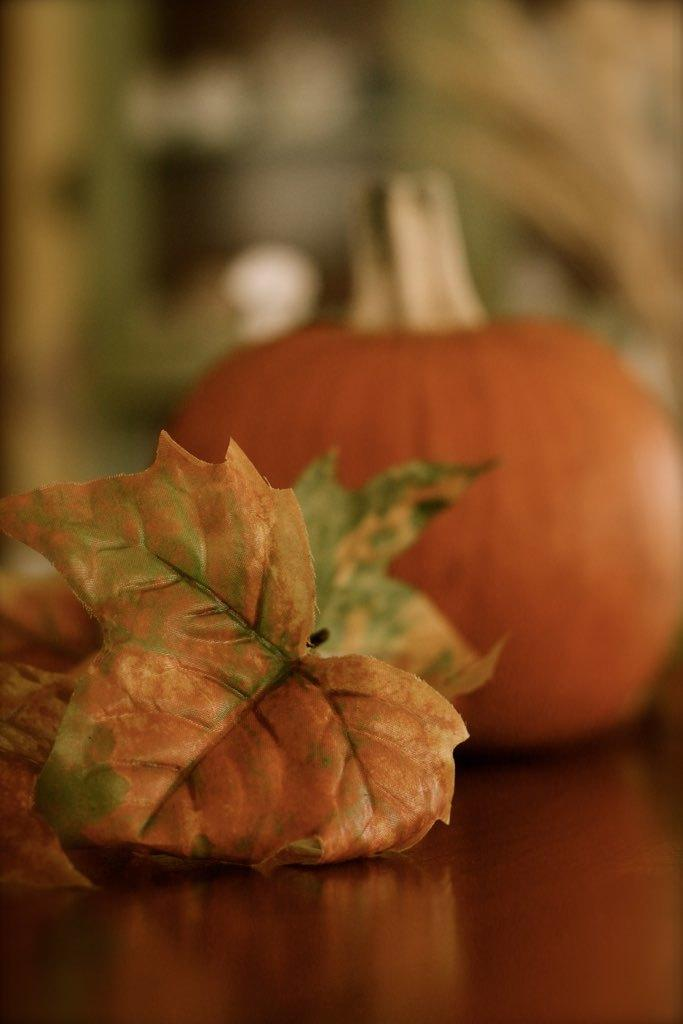What type of vegetation can be seen in the image? There are leaves in the image. What other object can be seen in the image? There is a pumpkin in the image. Where are the leaves and pumpkin located? The leaves and pumpkin are on a table. How would you describe the background of the image? The background of the image is blurry. What type of carriage can be seen in the image? There is no carriage present in the image. What type of office equipment can be seen in the image? There is no office equipment present in the image. 